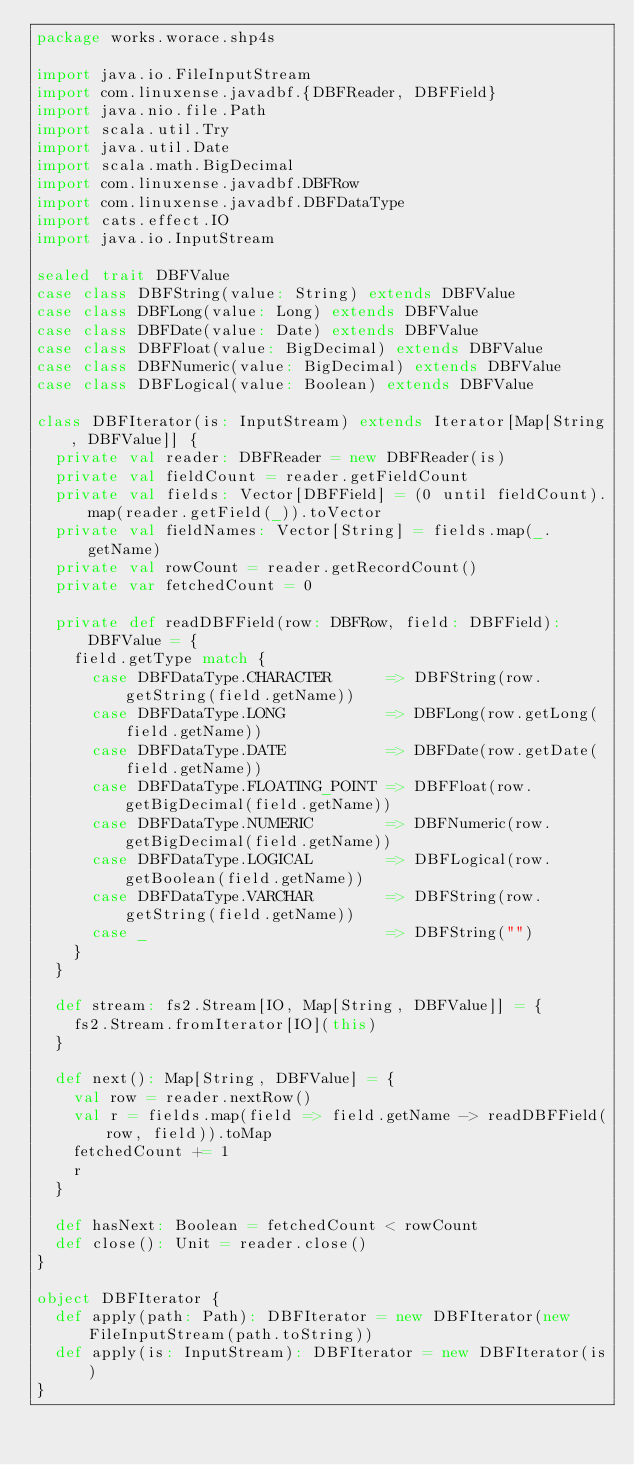Convert code to text. <code><loc_0><loc_0><loc_500><loc_500><_Scala_>package works.worace.shp4s

import java.io.FileInputStream
import com.linuxense.javadbf.{DBFReader, DBFField}
import java.nio.file.Path
import scala.util.Try
import java.util.Date
import scala.math.BigDecimal
import com.linuxense.javadbf.DBFRow
import com.linuxense.javadbf.DBFDataType
import cats.effect.IO
import java.io.InputStream

sealed trait DBFValue
case class DBFString(value: String) extends DBFValue
case class DBFLong(value: Long) extends DBFValue
case class DBFDate(value: Date) extends DBFValue
case class DBFFloat(value: BigDecimal) extends DBFValue
case class DBFNumeric(value: BigDecimal) extends DBFValue
case class DBFLogical(value: Boolean) extends DBFValue

class DBFIterator(is: InputStream) extends Iterator[Map[String, DBFValue]] {
  private val reader: DBFReader = new DBFReader(is)
  private val fieldCount = reader.getFieldCount
  private val fields: Vector[DBFField] = (0 until fieldCount).map(reader.getField(_)).toVector
  private val fieldNames: Vector[String] = fields.map(_.getName)
  private val rowCount = reader.getRecordCount()
  private var fetchedCount = 0

  private def readDBFField(row: DBFRow, field: DBFField): DBFValue = {
    field.getType match {
      case DBFDataType.CHARACTER      => DBFString(row.getString(field.getName))
      case DBFDataType.LONG           => DBFLong(row.getLong(field.getName))
      case DBFDataType.DATE           => DBFDate(row.getDate(field.getName))
      case DBFDataType.FLOATING_POINT => DBFFloat(row.getBigDecimal(field.getName))
      case DBFDataType.NUMERIC        => DBFNumeric(row.getBigDecimal(field.getName))
      case DBFDataType.LOGICAL        => DBFLogical(row.getBoolean(field.getName))
      case DBFDataType.VARCHAR        => DBFString(row.getString(field.getName))
      case _                          => DBFString("")
    }
  }

  def stream: fs2.Stream[IO, Map[String, DBFValue]] = {
    fs2.Stream.fromIterator[IO](this)
  }

  def next(): Map[String, DBFValue] = {
    val row = reader.nextRow()
    val r = fields.map(field => field.getName -> readDBFField(row, field)).toMap
    fetchedCount += 1
    r
  }

  def hasNext: Boolean = fetchedCount < rowCount
  def close(): Unit = reader.close()
}

object DBFIterator {
  def apply(path: Path): DBFIterator = new DBFIterator(new FileInputStream(path.toString))
  def apply(is: InputStream): DBFIterator = new DBFIterator(is)
}
</code> 